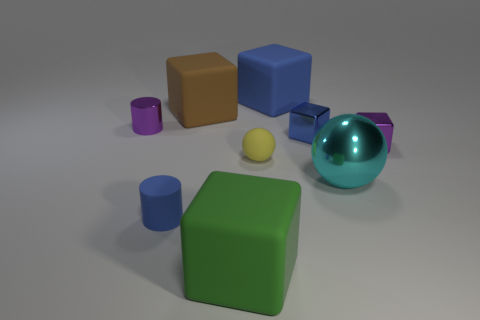The small purple object that is to the left of the blue cube that is behind the small block that is on the left side of the big shiny ball is made of what material?
Ensure brevity in your answer.  Metal. What material is the large thing that is in front of the big cyan sphere?
Your response must be concise. Rubber. Are there any blue metal things that have the same size as the rubber ball?
Give a very brief answer. Yes. There is a large rubber object that is right of the big green thing; is it the same color as the shiny cylinder?
Offer a very short reply. No. How many cyan objects are either large metal objects or metal things?
Your response must be concise. 1. What number of tiny metal things are the same color as the tiny metallic cylinder?
Offer a very short reply. 1. Are the green thing and the small yellow thing made of the same material?
Provide a succinct answer. Yes. There is a small shiny thing that is behind the small blue cube; what number of purple blocks are behind it?
Give a very brief answer. 0. Is the cyan ball the same size as the brown cube?
Your answer should be compact. Yes. What number of cylinders are the same material as the purple block?
Offer a very short reply. 1. 